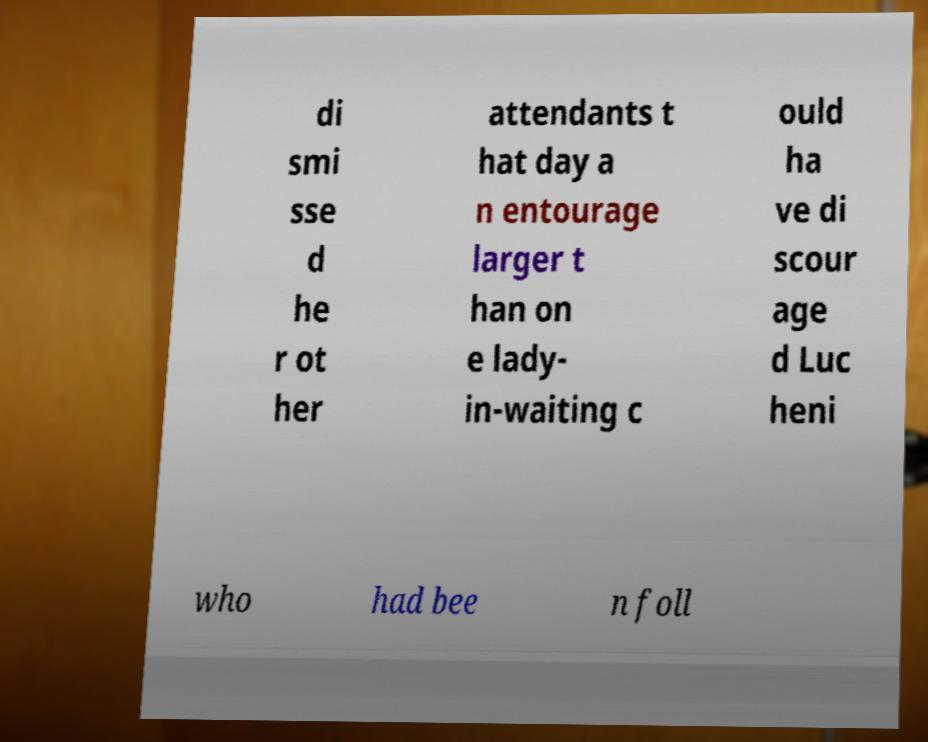Can you accurately transcribe the text from the provided image for me? di smi sse d he r ot her attendants t hat day a n entourage larger t han on e lady- in-waiting c ould ha ve di scour age d Luc heni who had bee n foll 